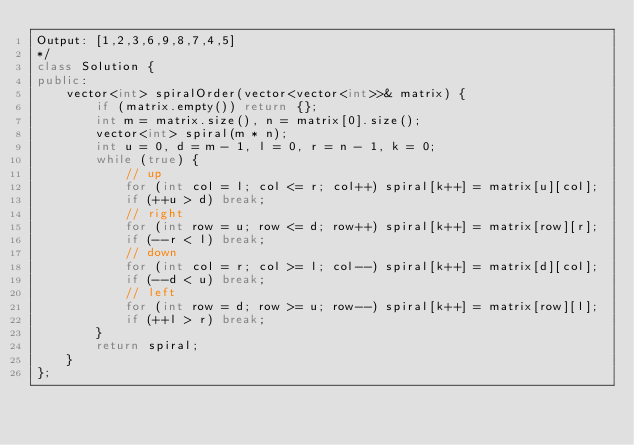Convert code to text. <code><loc_0><loc_0><loc_500><loc_500><_C++_>Output: [1,2,3,6,9,8,7,4,5]
*/
class Solution {
public:
    vector<int> spiralOrder(vector<vector<int>>& matrix) {
        if (matrix.empty()) return {};
        int m = matrix.size(), n = matrix[0].size();
        vector<int> spiral(m * n);
        int u = 0, d = m - 1, l = 0, r = n - 1, k = 0;
        while (true) {
            // up
            for (int col = l; col <= r; col++) spiral[k++] = matrix[u][col];
            if (++u > d) break;
            // right
            for (int row = u; row <= d; row++) spiral[k++] = matrix[row][r];
            if (--r < l) break;
            // down
            for (int col = r; col >= l; col--) spiral[k++] = matrix[d][col];
            if (--d < u) break;
            // left
            for (int row = d; row >= u; row--) spiral[k++] = matrix[row][l];
            if (++l > r) break;
        }
        return spiral;
    }
};
</code> 